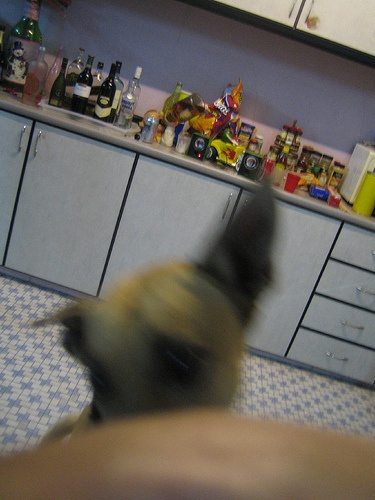Describe the objects in this image and their specific colors. I can see dog in darkblue, black, darkgreen, and gray tones, people in darkblue and gray tones, bottle in darkblue, black, gray, and maroon tones, microwave in darkblue, darkgray, and gray tones, and bottle in darkblue, maroon, gray, and black tones in this image. 